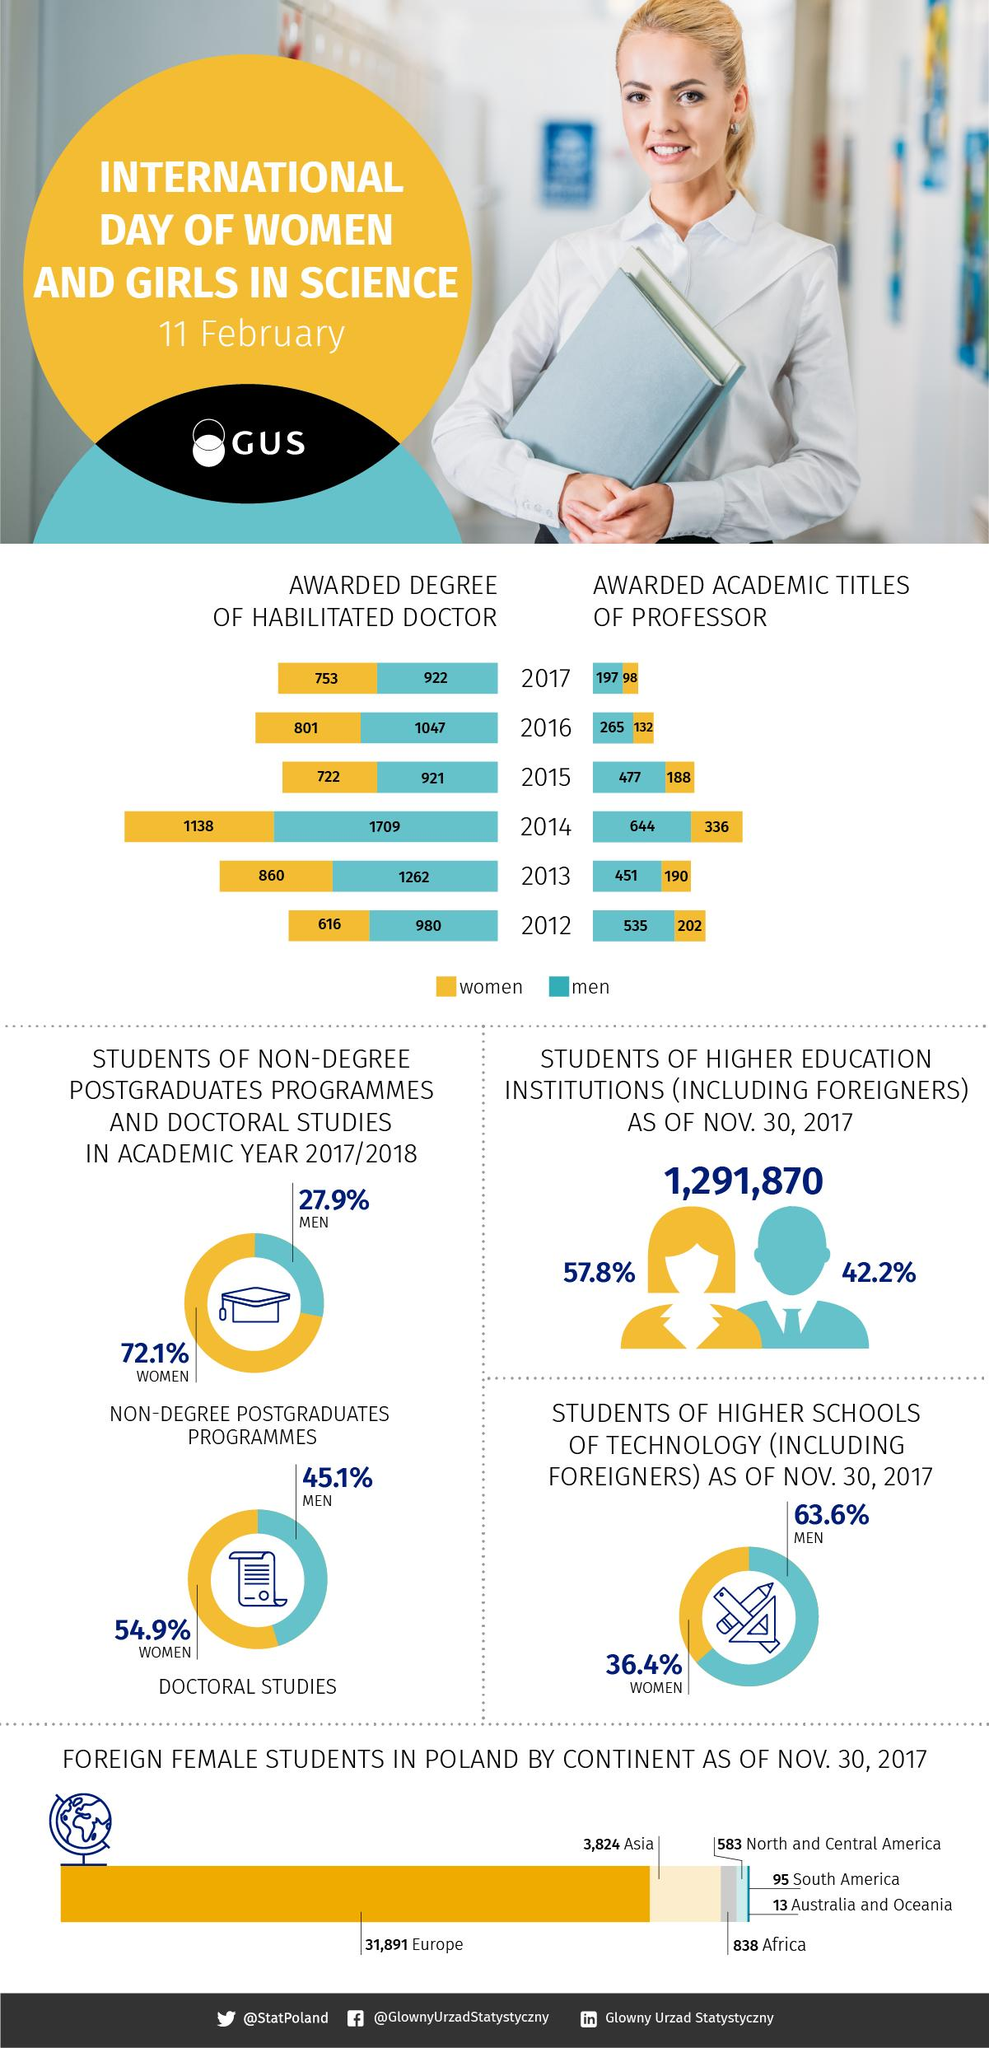Outline some significant characteristics in this image. In the year 2014, a total of 1138, 1709, 336, or 644 women were conferred PhDs, depending on the source of the information. In 2017, there were 607,178.9 foreign men students. In 2017, the number of professors conferred with a title for men was 197. The third lowest number of students studying in Poland came from North and Central America. The lowest number of PhDs conferred to women was in 2012. 